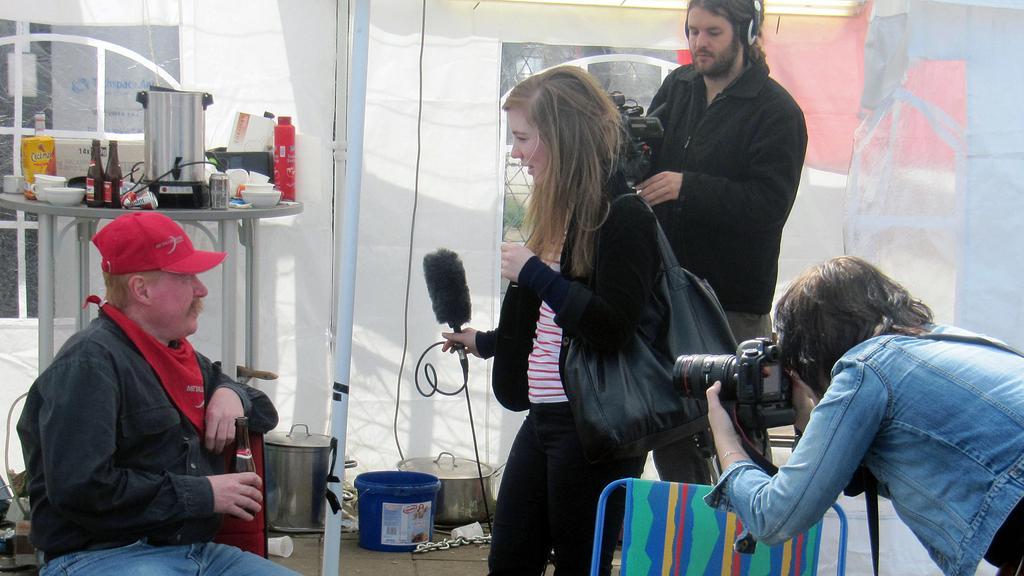Can you describe this image briefly? In the picture there is a man sitting on a chair he is being interviewed by the woman standing in front of him,behind her there is a man who is shooting the video to the left side there is another woman she is taking photographs,behind the man who is sitting there is a table and on the table there are some kitchen utensils on it, it looks like a tent there are also big vessels kept on the floor. 